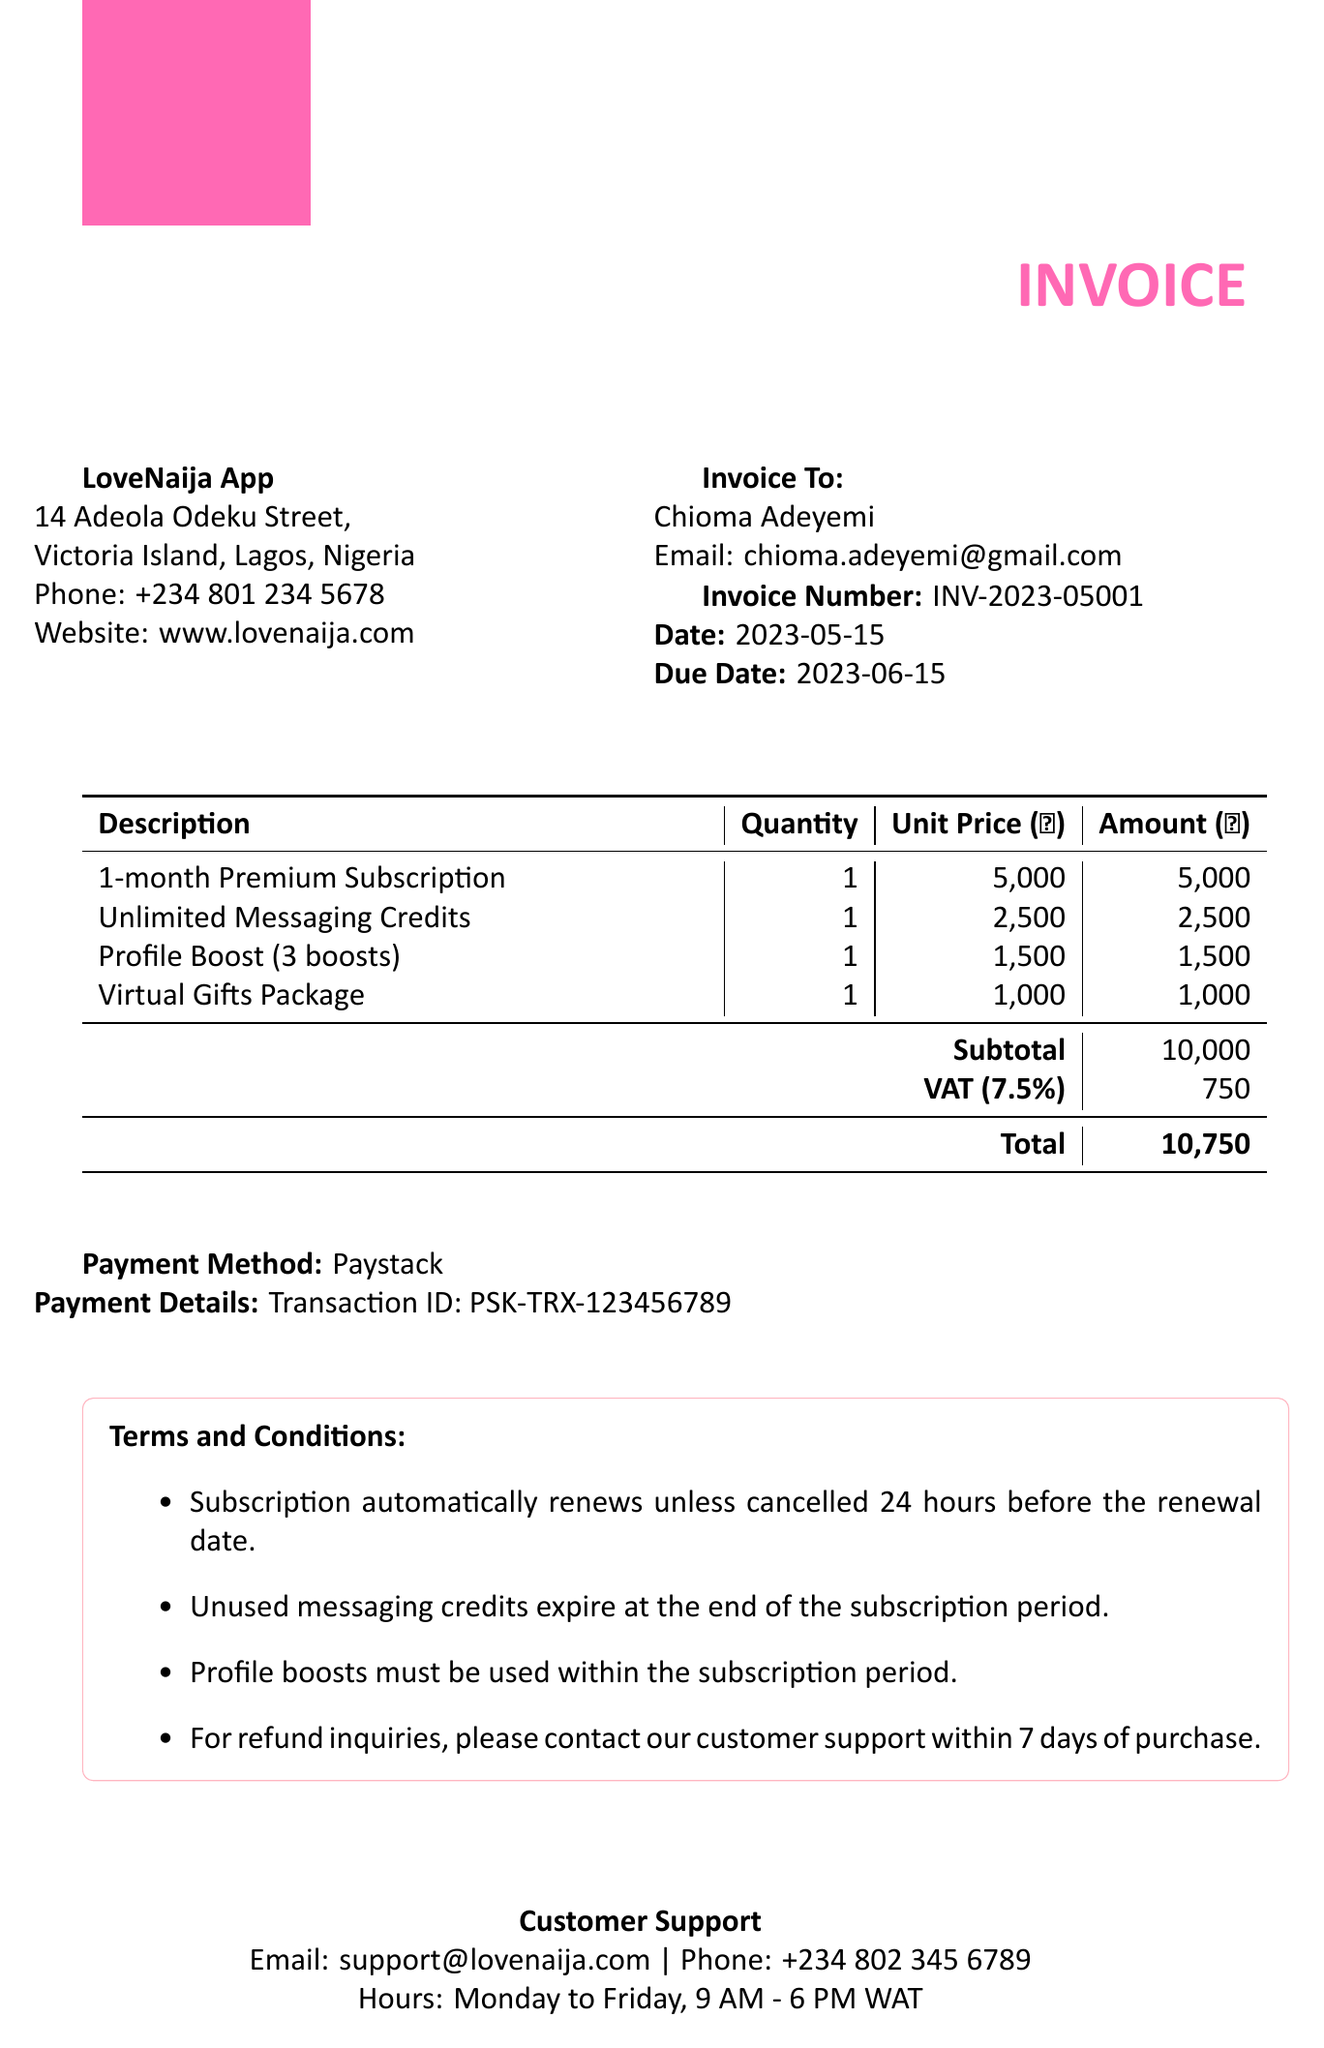What is the invoice number? The invoice number is a unique identifier assigned to this invoice.
Answer: INV-2023-05001 What is the total amount due? The total amount due is calculated by adding the subtotal and VAT.
Answer: 10,750 What is the customer's email address? The customer's email address is provided for communication regarding the invoice.
Answer: chioma.adeyemi@gmail.com What payment method was used? The payment method indicates how the transaction was processed.
Answer: Paystack What is the due date for payment? The due date specifies the last date when the payment should be made.
Answer: 2023-06-15 How many profile boosts are included? The quantity of profile boosts is included in the items list of the invoice.
Answer: 3 boosts What is the subtotal before VAT? The subtotal is the total amount for items before any additional taxes like VAT.
Answer: 10,000 What should be done if there are refund inquiries? The terms specify the procedure for handling refund inquiries.
Answer: Contact customer support within 7 days of purchase 